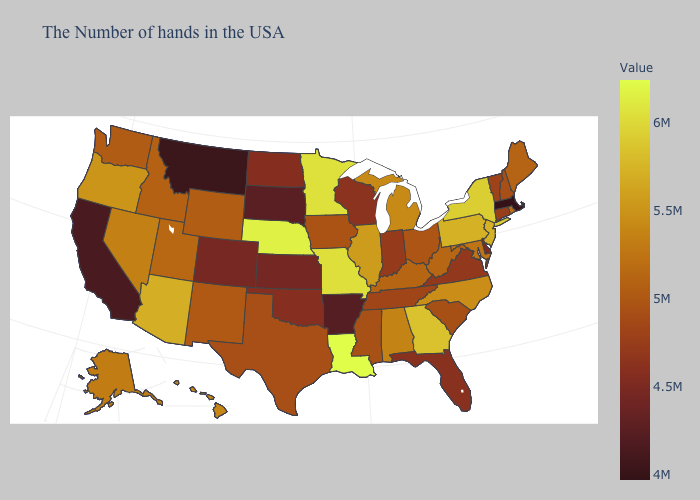Among the states that border Arizona , which have the lowest value?
Write a very short answer. California. Which states have the lowest value in the West?
Short answer required. Montana. Among the states that border Massachusetts , does Vermont have the highest value?
Quick response, please. No. 